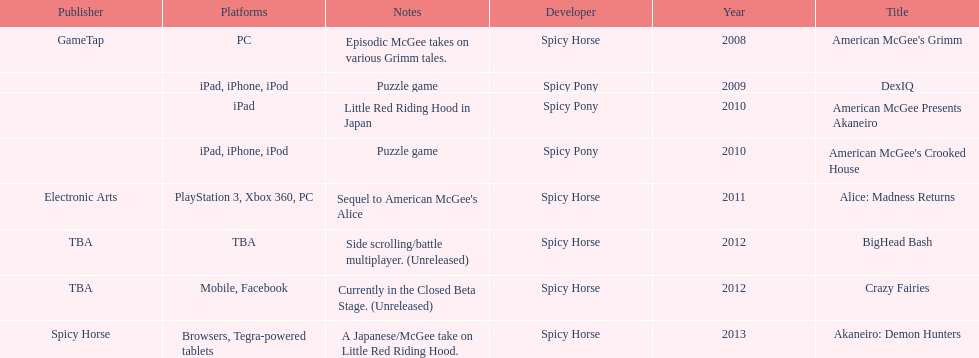What are the instances of ipad usage as a platform? 3. 